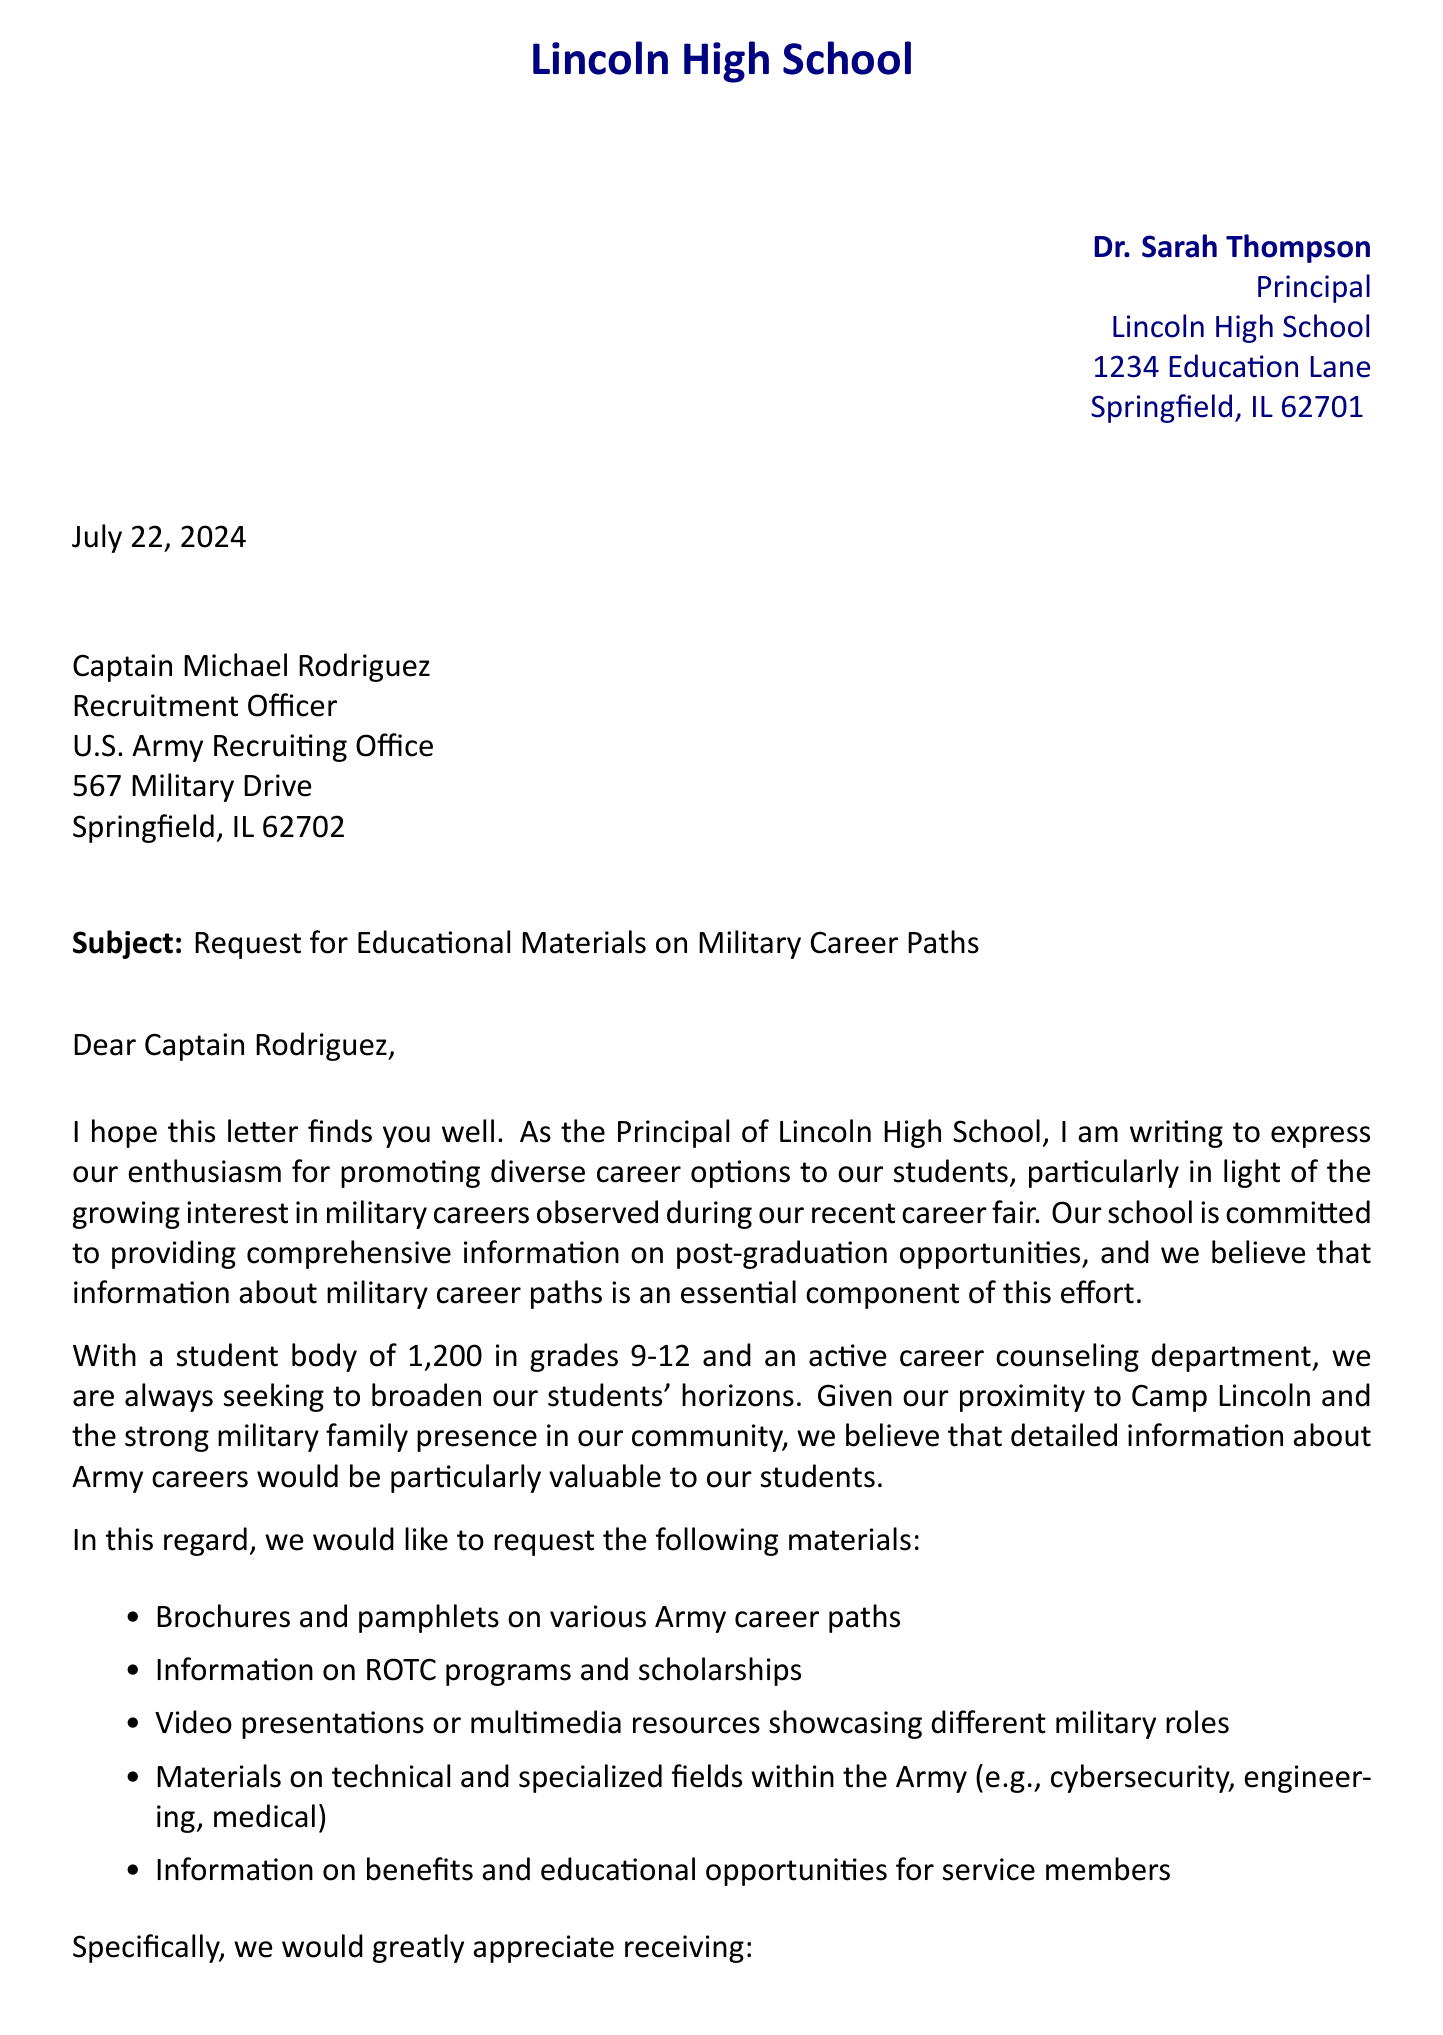what is the name of the sender? The sender is introduced at the beginning of the letter, and her name is Dr. Sarah Thompson.
Answer: Dr. Sarah Thompson who is the recipient of the letter? The recipient is specified in the letter as Captain Michael Rodriguez, who is the Recruitment Officer.
Answer: Captain Michael Rodriguez what is the date of the letter? The letter includes a placeholder for the date, indicated as "today" which refers to the date when the letter is rendered.
Answer: today how many students are in the school? The document states that the student body consists of 1,200 students.
Answer: 1,200 what specific document is requested regarding ROTC? The letter requests an overview specifically titled "ROTC Program Overview".
Answer: ROTC Program Overview name one of the specialized fields mentioned in the letter. The letter lists several technical and specialized fields, one of which is cybersecurity.
Answer: cybersecurity what materials are requested to show military career paths? The letter requests brochures and pamphlets on various Army career paths.
Answer: brochures and pamphlets how many alumni are currently serving in the military? The letter mentions that 15 alumni from the school are currently serving in various branches of the military.
Answer: 15 what is the main purpose of the letter? The primary purpose of the letter is to request educational materials on military career paths for students.
Answer: request educational materials 